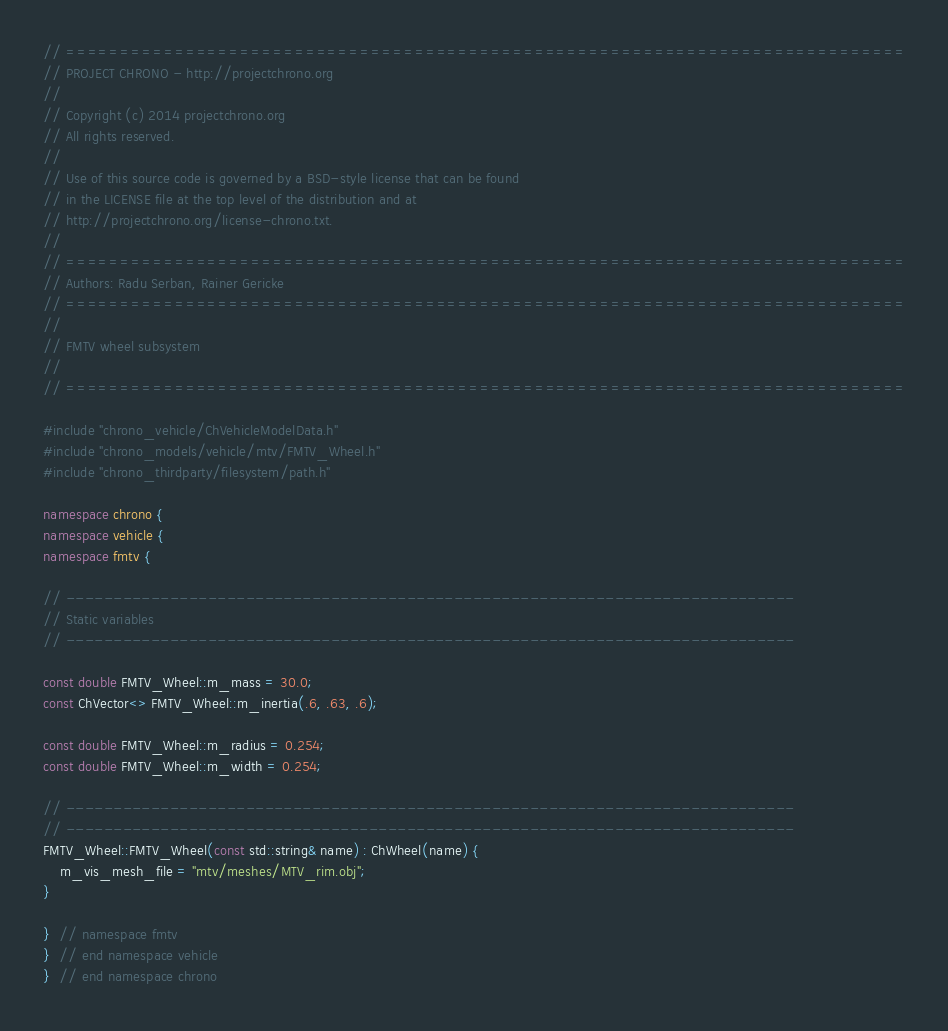Convert code to text. <code><loc_0><loc_0><loc_500><loc_500><_C++_>// =============================================================================
// PROJECT CHRONO - http://projectchrono.org
//
// Copyright (c) 2014 projectchrono.org
// All rights reserved.
//
// Use of this source code is governed by a BSD-style license that can be found
// in the LICENSE file at the top level of the distribution and at
// http://projectchrono.org/license-chrono.txt.
//
// =============================================================================
// Authors: Radu Serban, Rainer Gericke
// =============================================================================
//
// FMTV wheel subsystem
//
// =============================================================================

#include "chrono_vehicle/ChVehicleModelData.h"
#include "chrono_models/vehicle/mtv/FMTV_Wheel.h"
#include "chrono_thirdparty/filesystem/path.h"

namespace chrono {
namespace vehicle {
namespace fmtv {

// -----------------------------------------------------------------------------
// Static variables
// -----------------------------------------------------------------------------

const double FMTV_Wheel::m_mass = 30.0;
const ChVector<> FMTV_Wheel::m_inertia(.6, .63, .6);

const double FMTV_Wheel::m_radius = 0.254;
const double FMTV_Wheel::m_width = 0.254;

// -----------------------------------------------------------------------------
// -----------------------------------------------------------------------------
FMTV_Wheel::FMTV_Wheel(const std::string& name) : ChWheel(name) {
    m_vis_mesh_file = "mtv/meshes/MTV_rim.obj";
}

}  // namespace fmtv
}  // end namespace vehicle
}  // end namespace chrono
</code> 